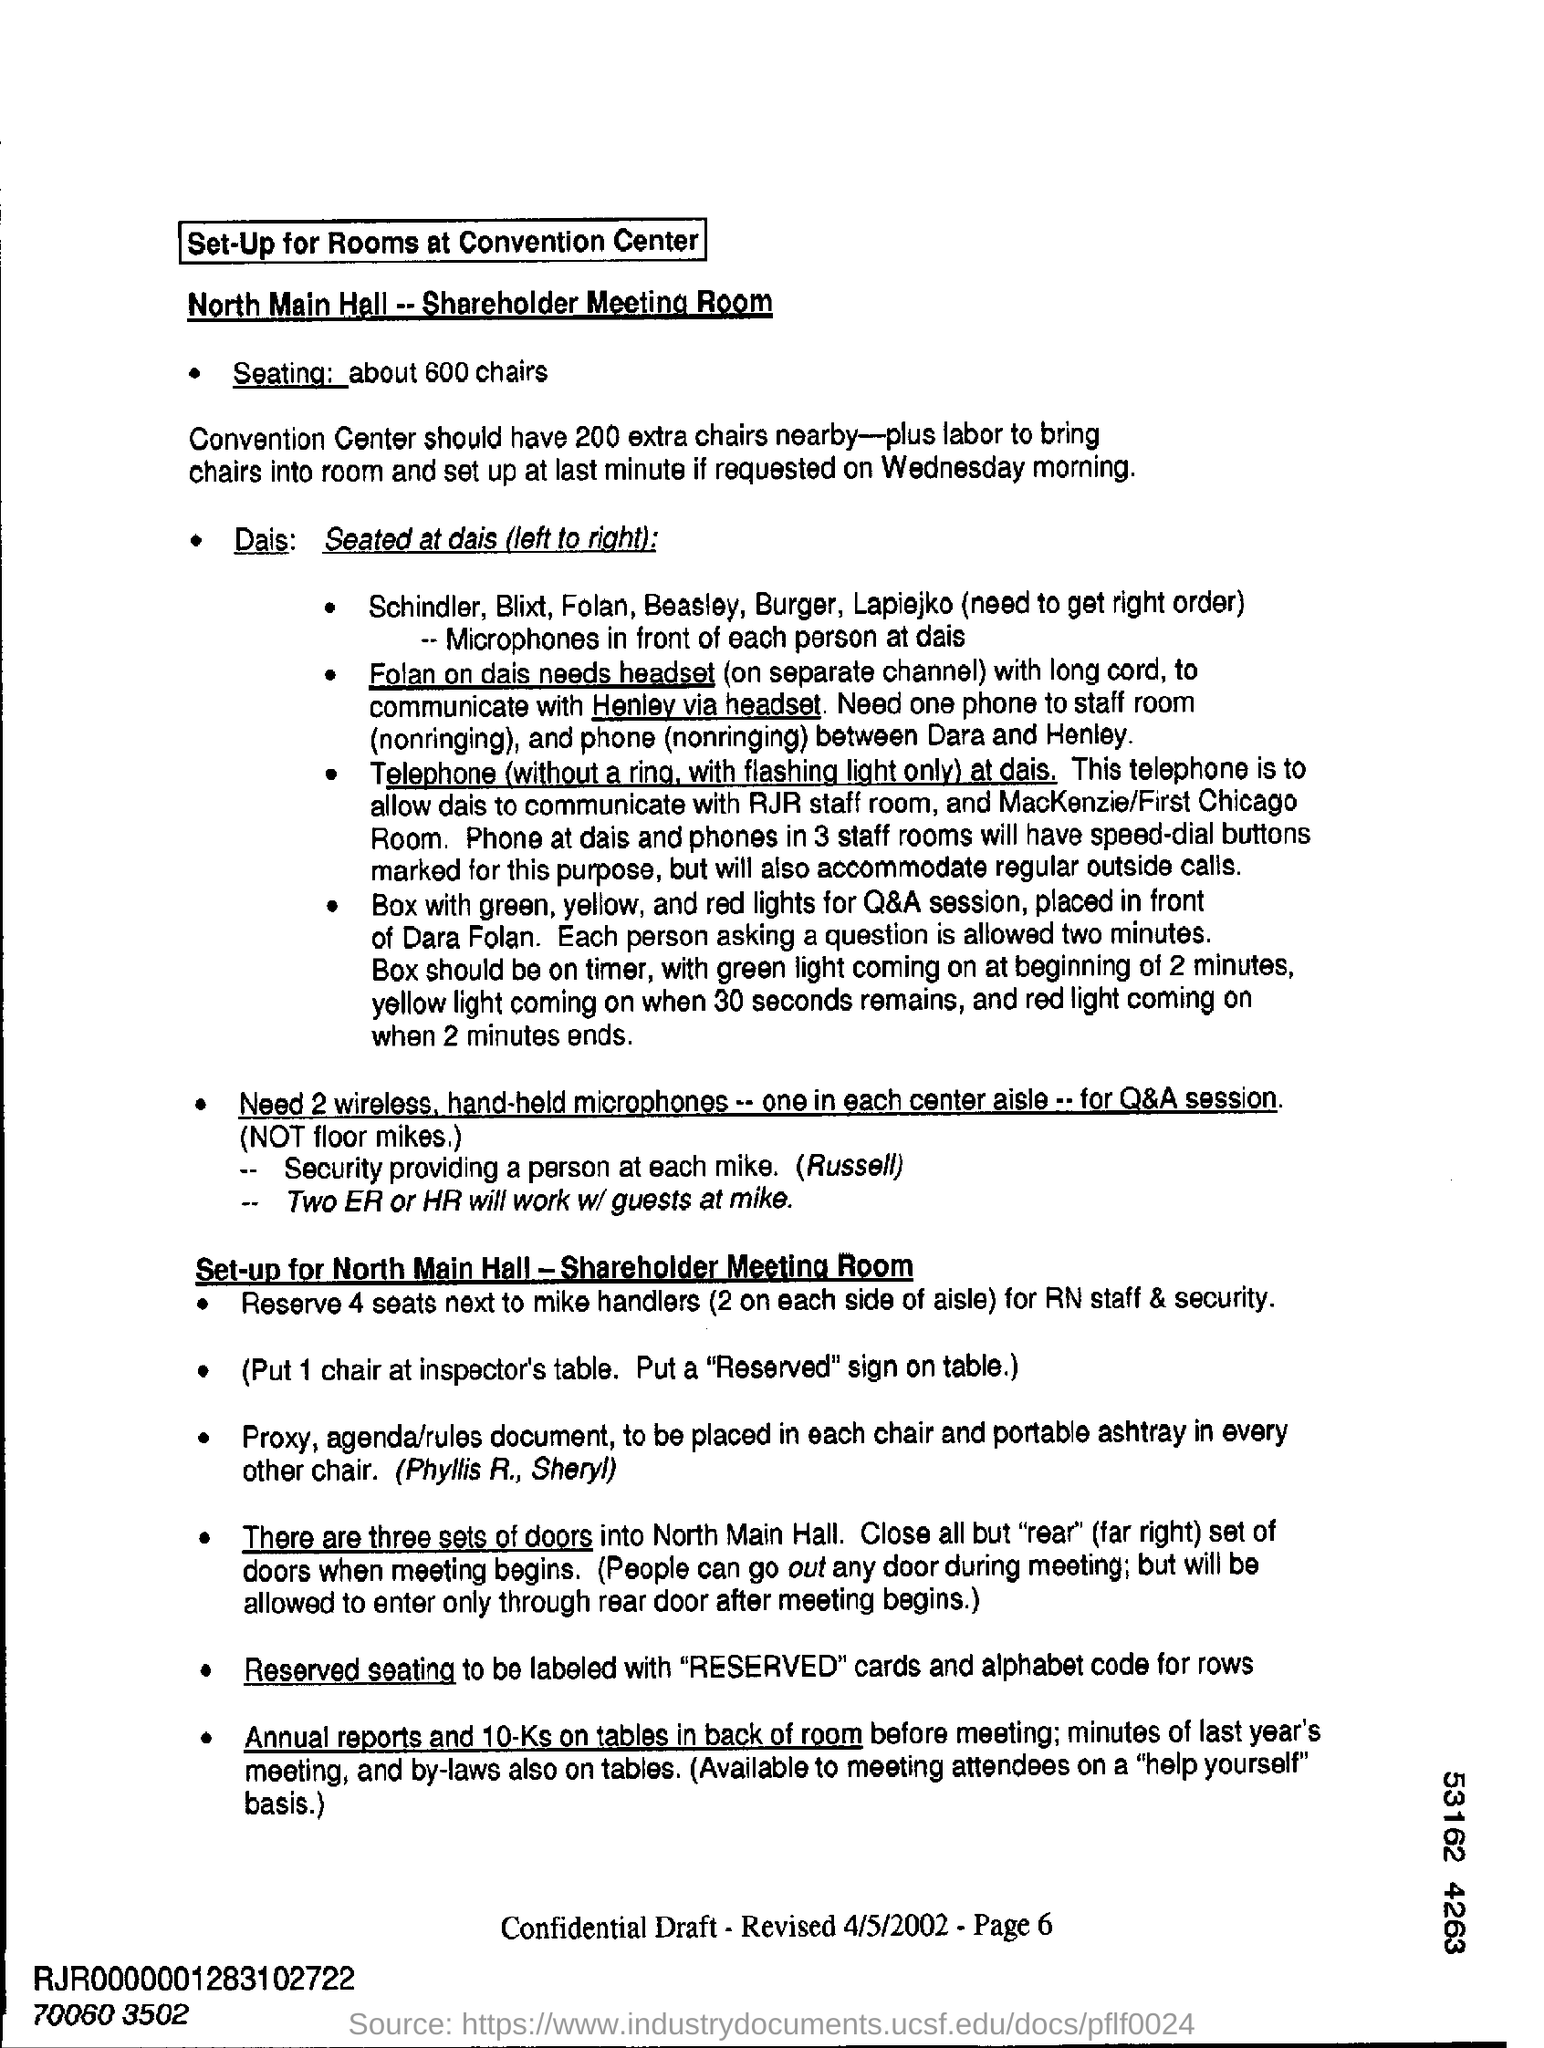Mention a couple of crucial points in this snapshot. It is necessary to provide 200 additional chairs at the Convention Center. There is one chair placed at the Inspector's table. 